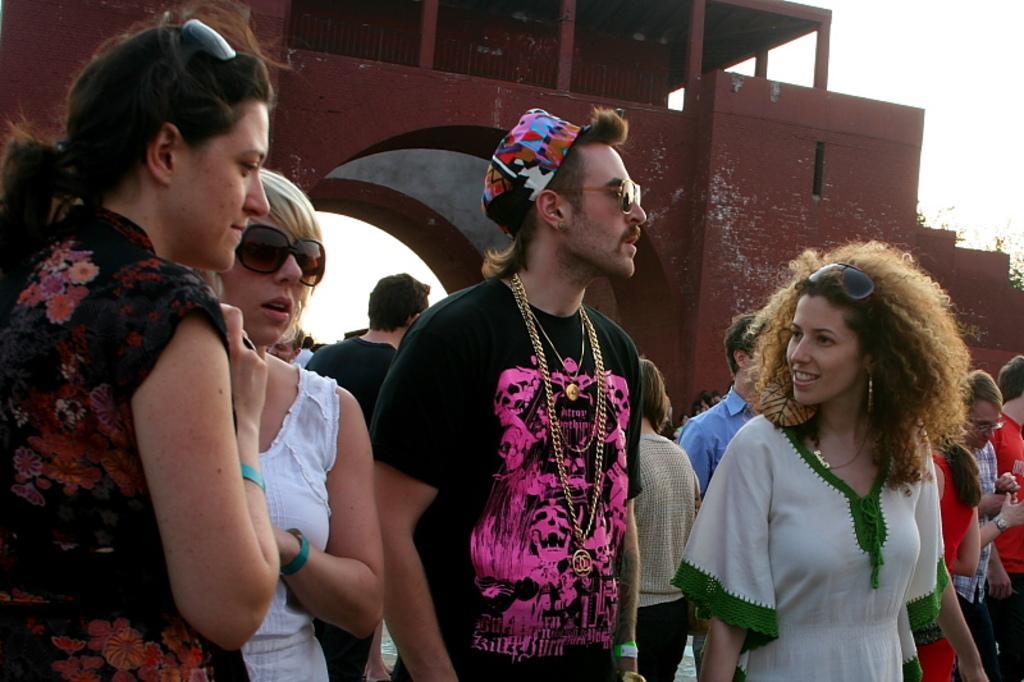Can you describe this image briefly? In this image, we can see people standing and some are wearing glasses and we can see a person wearing chains and a cap. In the background, we can see a fort. 